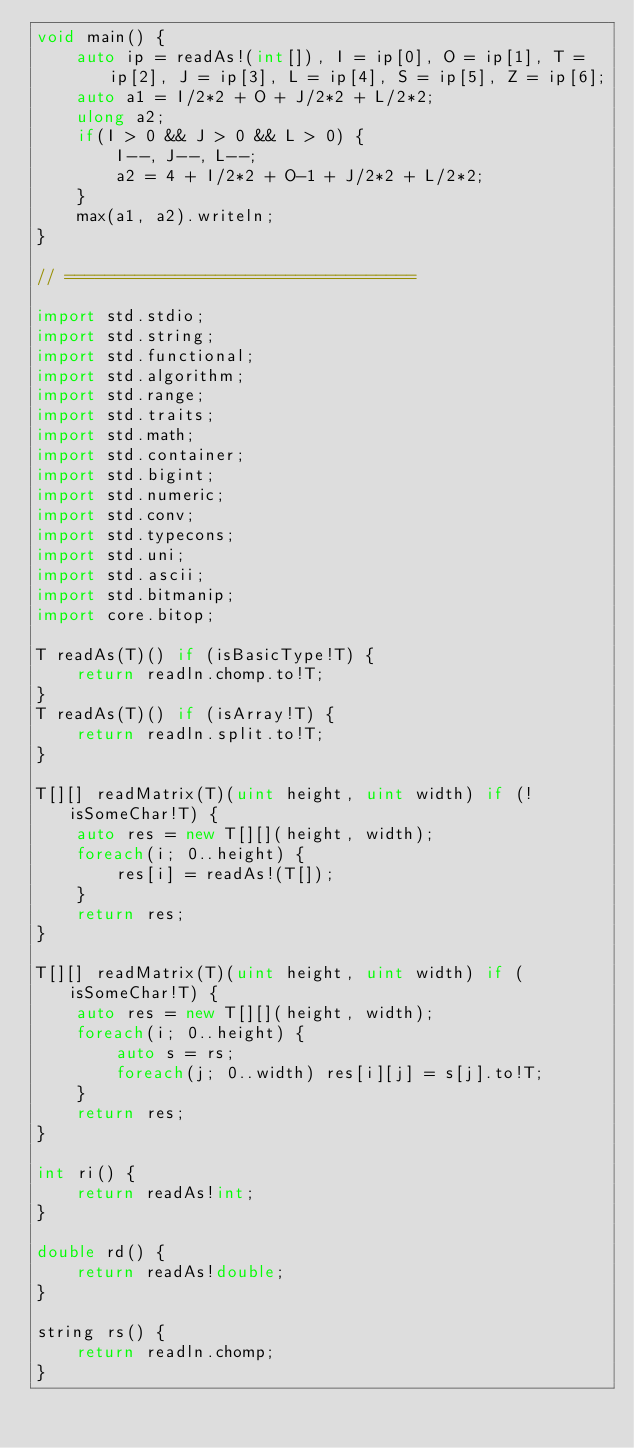Convert code to text. <code><loc_0><loc_0><loc_500><loc_500><_D_>void main() {
	auto ip = readAs!(int[]), I = ip[0], O = ip[1], T = ip[2], J = ip[3], L = ip[4], S = ip[5], Z = ip[6];
	auto a1 = I/2*2 + O + J/2*2 + L/2*2;
	ulong a2;
	if(I > 0 && J > 0 && L > 0) {
		I--, J--, L--;
		a2 = 4 + I/2*2 + O-1 + J/2*2 + L/2*2;
	}
	max(a1, a2).writeln;
}

// ===================================

import std.stdio;
import std.string;
import std.functional;
import std.algorithm;
import std.range;
import std.traits;
import std.math;
import std.container;
import std.bigint;
import std.numeric;
import std.conv;
import std.typecons;
import std.uni;
import std.ascii;
import std.bitmanip;
import core.bitop;

T readAs(T)() if (isBasicType!T) {
	return readln.chomp.to!T;
}
T readAs(T)() if (isArray!T) {
	return readln.split.to!T;
}

T[][] readMatrix(T)(uint height, uint width) if (!isSomeChar!T) {
	auto res = new T[][](height, width);
	foreach(i; 0..height) {
		res[i] = readAs!(T[]);
	}
	return res;
}

T[][] readMatrix(T)(uint height, uint width) if (isSomeChar!T) {
	auto res = new T[][](height, width);
	foreach(i; 0..height) {
		auto s = rs;
		foreach(j; 0..width) res[i][j] = s[j].to!T;
	}
	return res;
}

int ri() {
	return readAs!int;
}

double rd() {
	return readAs!double;
}

string rs() {
	return readln.chomp;
}
</code> 